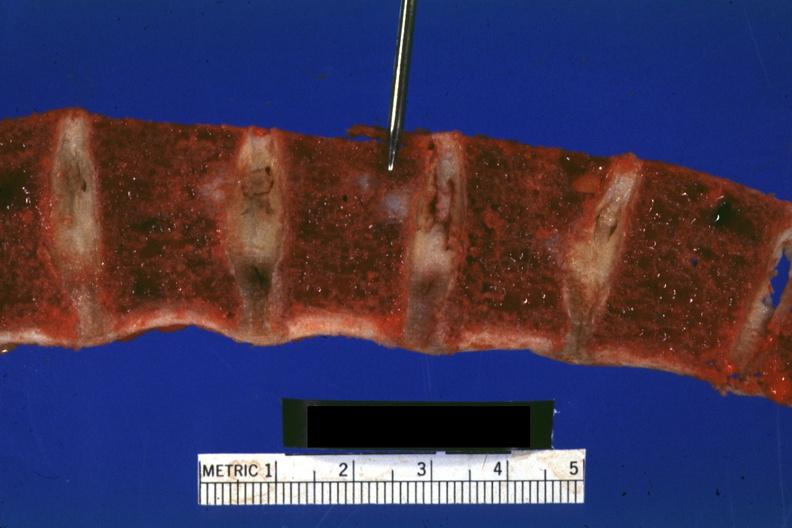what is present?
Answer the question using a single word or phrase. Joints 